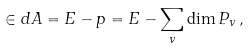<formula> <loc_0><loc_0><loc_500><loc_500>\in d A = E - p = E - \sum _ { v } \dim P _ { v } \, ,</formula> 